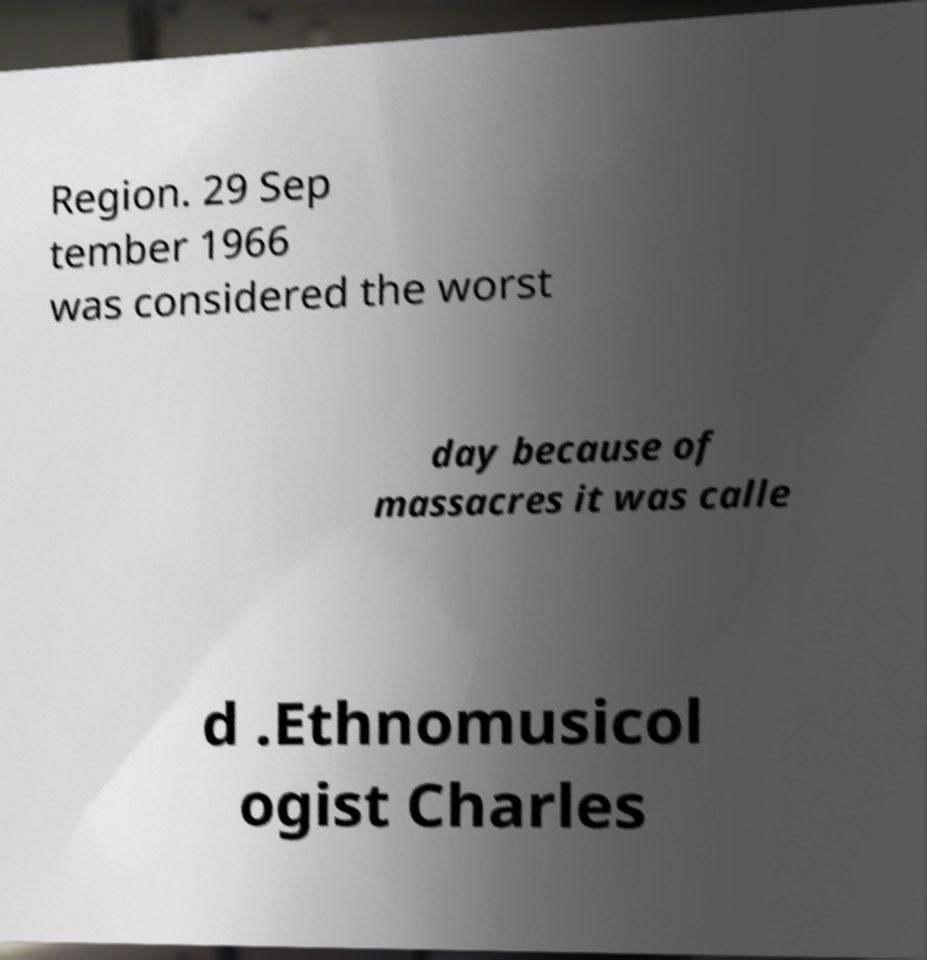There's text embedded in this image that I need extracted. Can you transcribe it verbatim? Region. 29 Sep tember 1966 was considered the worst day because of massacres it was calle d .Ethnomusicol ogist Charles 